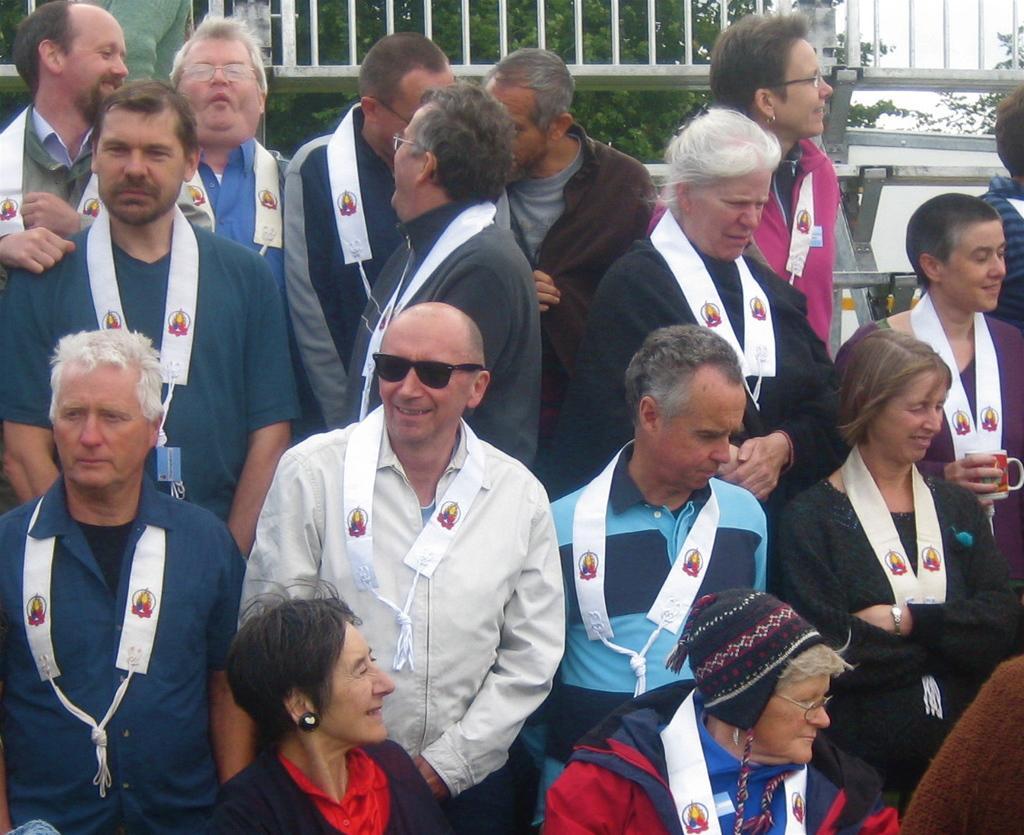Please provide a concise description of this image. In this image I see number of people and I see white color things around their necks and I see the fencing over here and I see the green leaves in the background. 